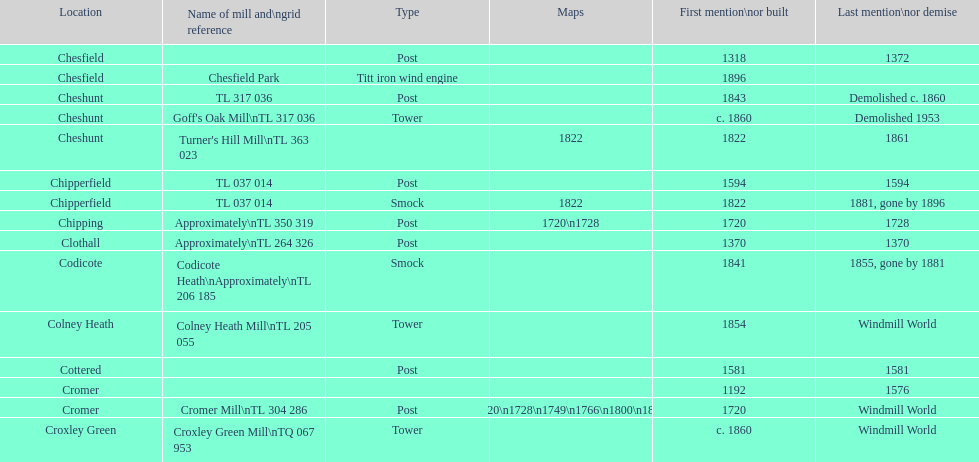Help me parse the entirety of this table. {'header': ['Location', 'Name of mill and\\ngrid reference', 'Type', 'Maps', 'First mention\\nor built', 'Last mention\\nor demise'], 'rows': [['Chesfield', '', 'Post', '', '1318', '1372'], ['Chesfield', 'Chesfield Park', 'Titt iron wind engine', '', '1896', ''], ['Cheshunt', 'TL 317 036', 'Post', '', '1843', 'Demolished c. 1860'], ['Cheshunt', "Goff's Oak Mill\\nTL 317 036", 'Tower', '', 'c. 1860', 'Demolished 1953'], ['Cheshunt', "Turner's Hill Mill\\nTL 363 023", '', '1822', '1822', '1861'], ['Chipperfield', 'TL 037 014', 'Post', '', '1594', '1594'], ['Chipperfield', 'TL 037 014', 'Smock', '1822', '1822', '1881, gone by 1896'], ['Chipping', 'Approximately\\nTL 350 319', 'Post', '1720\\n1728', '1720', '1728'], ['Clothall', 'Approximately\\nTL 264 326', 'Post', '', '1370', '1370'], ['Codicote', 'Codicote Heath\\nApproximately\\nTL 206 185', 'Smock', '', '1841', '1855, gone by 1881'], ['Colney Heath', 'Colney Heath Mill\\nTL 205 055', 'Tower', '', '1854', 'Windmill World'], ['Cottered', '', 'Post', '', '1581', '1581'], ['Cromer', '', '', '', '1192', '1576'], ['Cromer', 'Cromer Mill\\nTL 304 286', 'Post', '1720\\n1728\\n1749\\n1766\\n1800\\n1822', '1720', 'Windmill World'], ['Croxley Green', 'Croxley Green Mill\\nTQ 067 953', 'Tower', '', 'c. 1860', 'Windmill World']]} What is the number of mills first mentioned or built in the 1800s? 8. 